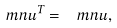<formula> <loc_0><loc_0><loc_500><loc_500>\ m n u ^ { T } = \ m n u ,</formula> 